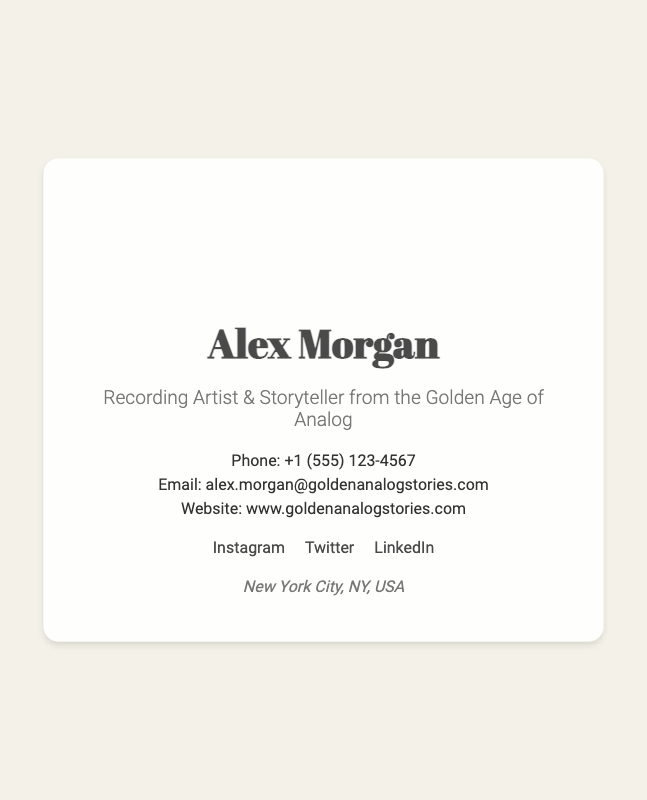what is the name on the business card? The name on the business card is prominently displayed at the top of the card.
Answer: Alex Morgan what is the phone number listed? The phone number is included in the contact information section of the card.
Answer: +1 (555) 123-4567 what city is mentioned on the business card? The city is indicated in the location section at the bottom of the card.
Answer: New York City what is the email address provided? The email address can be found within the contact information section.
Answer: alex.morgan@goldenanalogstories.com how many social media links are present? The number of social media links can be counted in the social media section of the card.
Answer: 3 what is the occupation title on the business card? The occupation title is described directly under the name on the card.
Answer: Recording Artist & Storyteller which style of music is implied by the title? The title suggests a specific era of music history mentioned in the occupation.
Answer: Golden Age of Analog what is the background of the business card? The background is specified as part of the visual design element of the card.
Answer: Recording Studio Background what is the primary color scheme indicated on the card? The primary colors can be inferred from the overall design and text color.
Answer: White and brown 